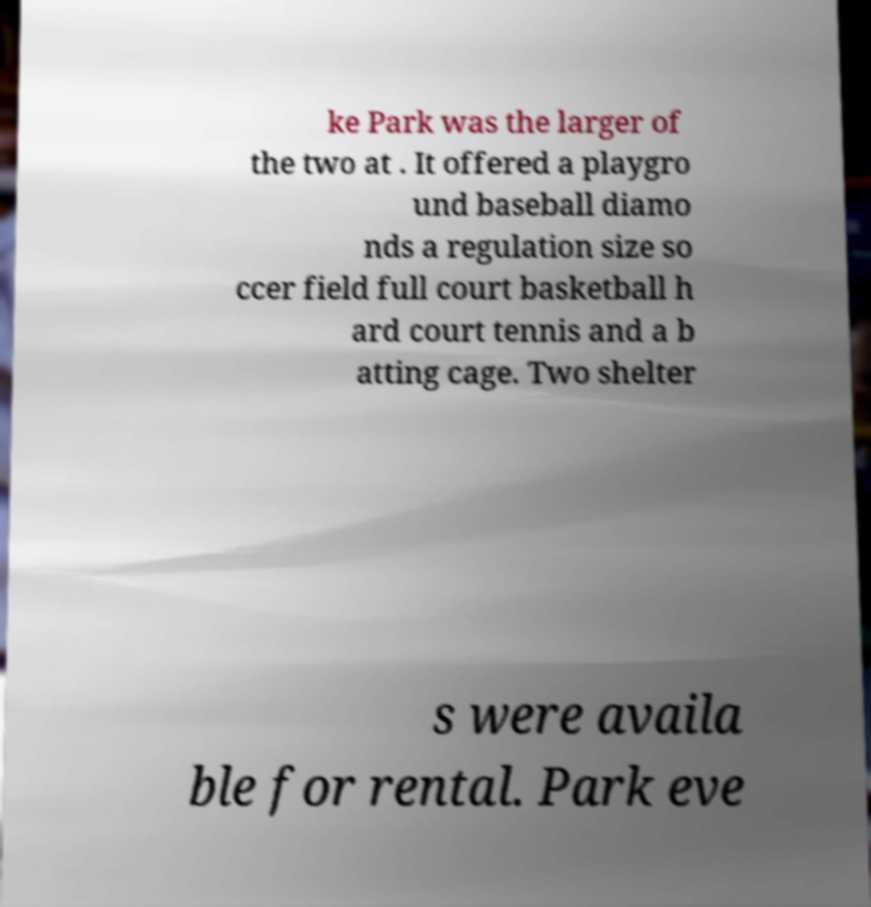I need the written content from this picture converted into text. Can you do that? ke Park was the larger of the two at . It offered a playgro und baseball diamo nds a regulation size so ccer field full court basketball h ard court tennis and a b atting cage. Two shelter s were availa ble for rental. Park eve 